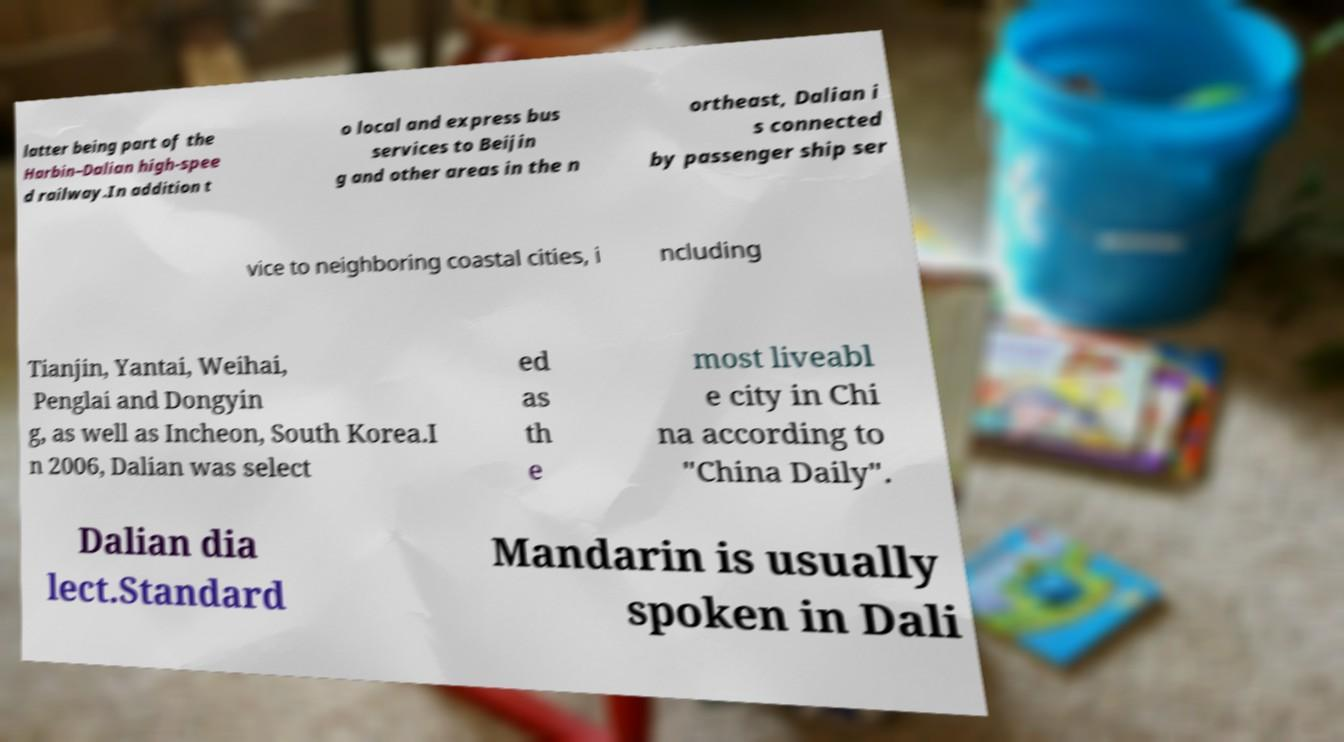Please identify and transcribe the text found in this image. latter being part of the Harbin–Dalian high-spee d railway.In addition t o local and express bus services to Beijin g and other areas in the n ortheast, Dalian i s connected by passenger ship ser vice to neighboring coastal cities, i ncluding Tianjin, Yantai, Weihai, Penglai and Dongyin g, as well as Incheon, South Korea.I n 2006, Dalian was select ed as th e most liveabl e city in Chi na according to "China Daily". Dalian dia lect.Standard Mandarin is usually spoken in Dali 